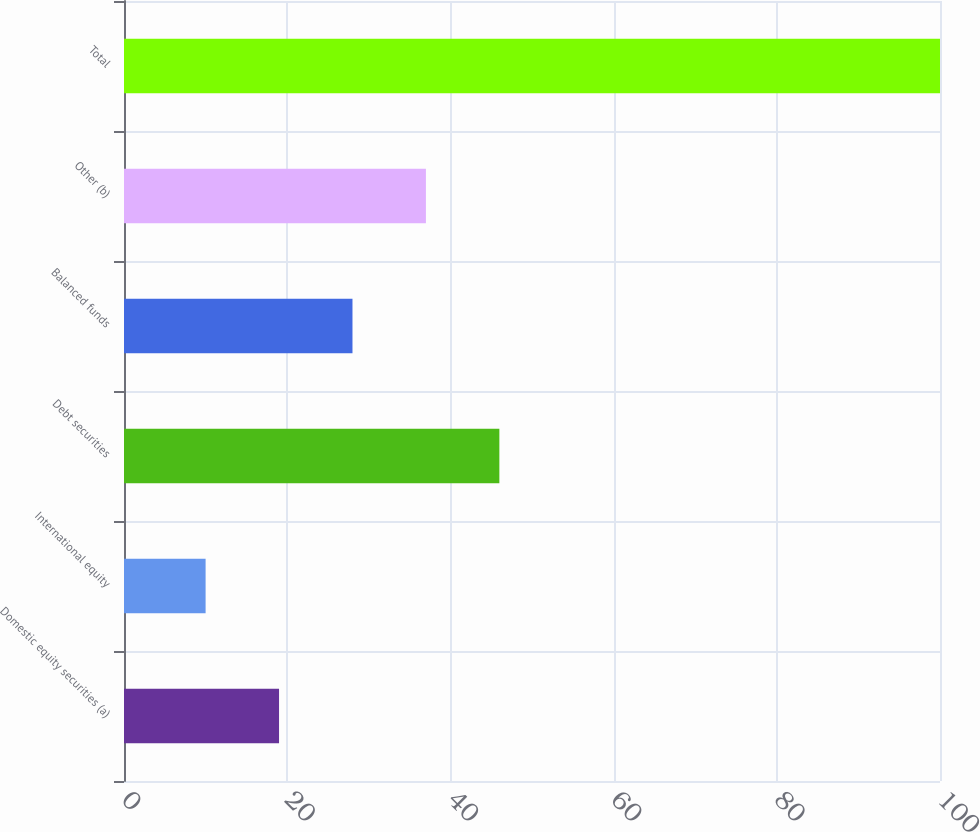Convert chart to OTSL. <chart><loc_0><loc_0><loc_500><loc_500><bar_chart><fcel>Domestic equity securities (a)<fcel>International equity<fcel>Debt securities<fcel>Balanced funds<fcel>Other (b)<fcel>Total<nl><fcel>19<fcel>10<fcel>46<fcel>28<fcel>37<fcel>100<nl></chart> 